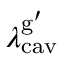Convert formula to latex. <formula><loc_0><loc_0><loc_500><loc_500>{ \lambda _ { c a v } ^ { g ^ { \prime } } }</formula> 